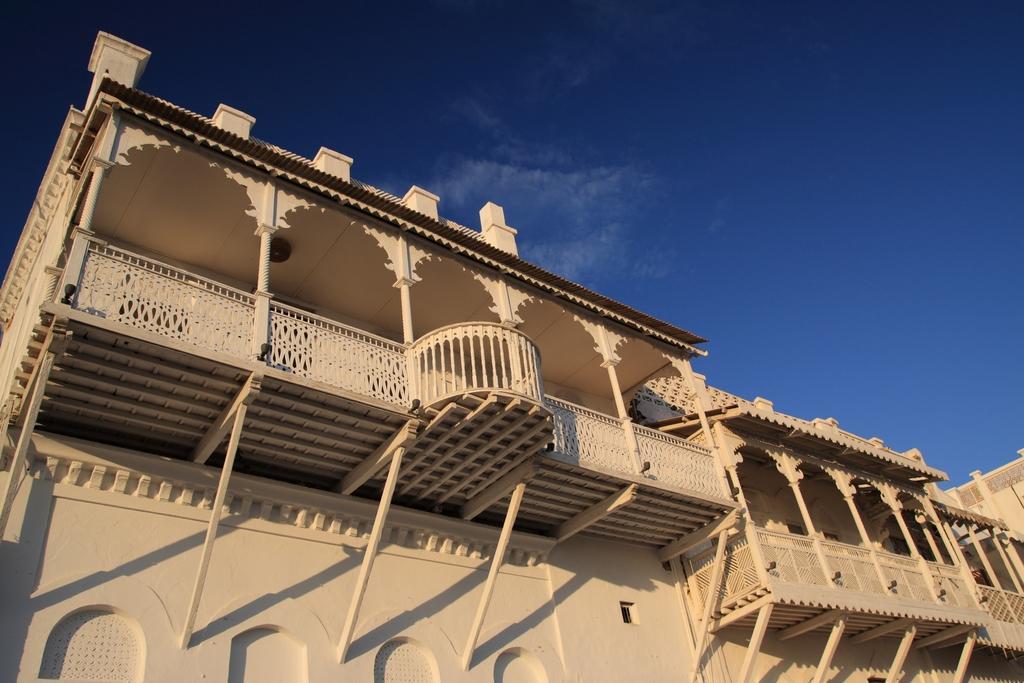Describe this image in one or two sentences. As we can see in the image there are buildings, fence and sky. 